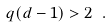<formula> <loc_0><loc_0><loc_500><loc_500>q ( d - 1 ) > 2 \ .</formula> 